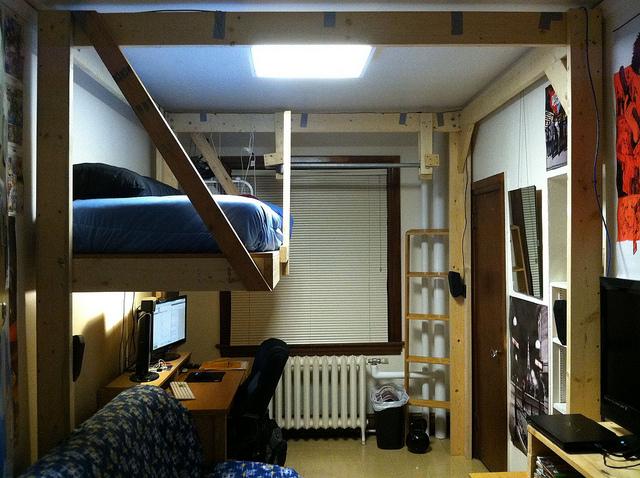What kind of bed is there?
Quick response, please. Bunk. What is sitting under the window?
Quick response, please. Radiator. Was the bed handmade?
Answer briefly. Yes. 